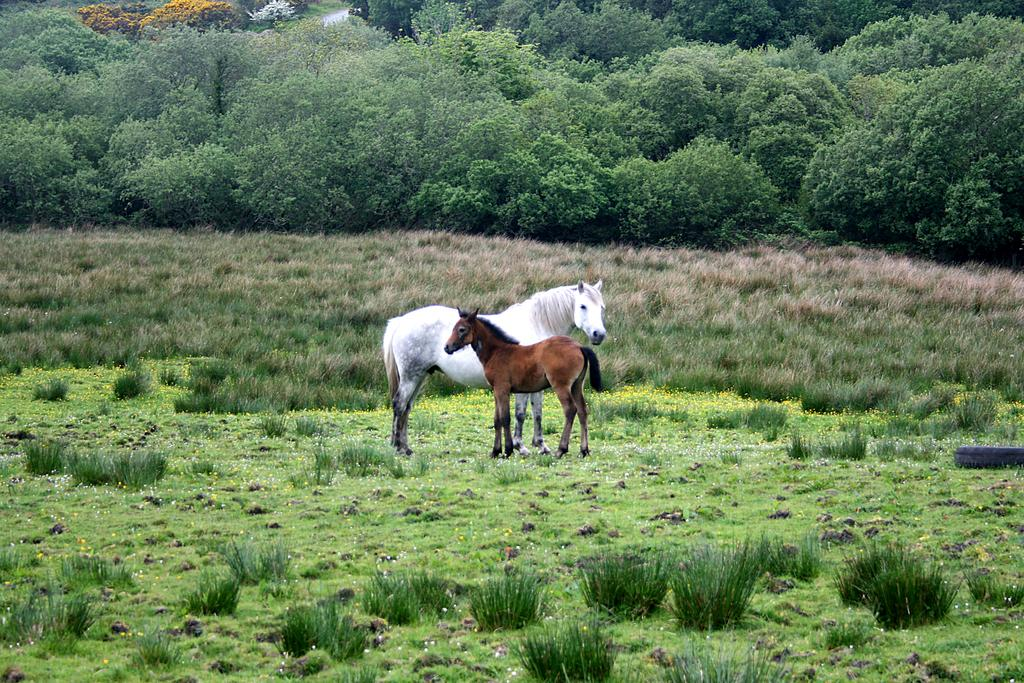How many horses are in the image? There are two horses in the image, a white horse and a brown horse. What is the position of the horses in the image? The horses are on the ground in the image. What type of vegetation is present on the ground? There are grasses on the ground in the image. What can be seen in the background of the image? There are trees in the background of the image. How many passengers are riding the horses in the image? There are no passengers riding the horses in the image; the horses are on the ground without any riders. Can you see any kissing happening between the horses in the image? There is no kissing happening between the horses in the image; they are simply standing on the ground. 